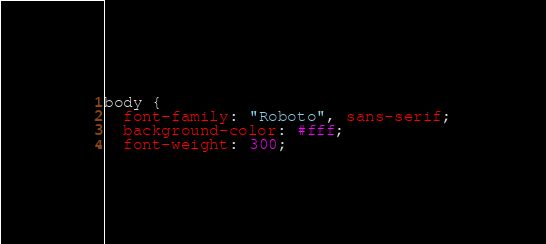Convert code to text. <code><loc_0><loc_0><loc_500><loc_500><_CSS_>body {
  font-family: "Roboto", sans-serif;
  background-color: #fff;
  font-weight: 300;</code> 